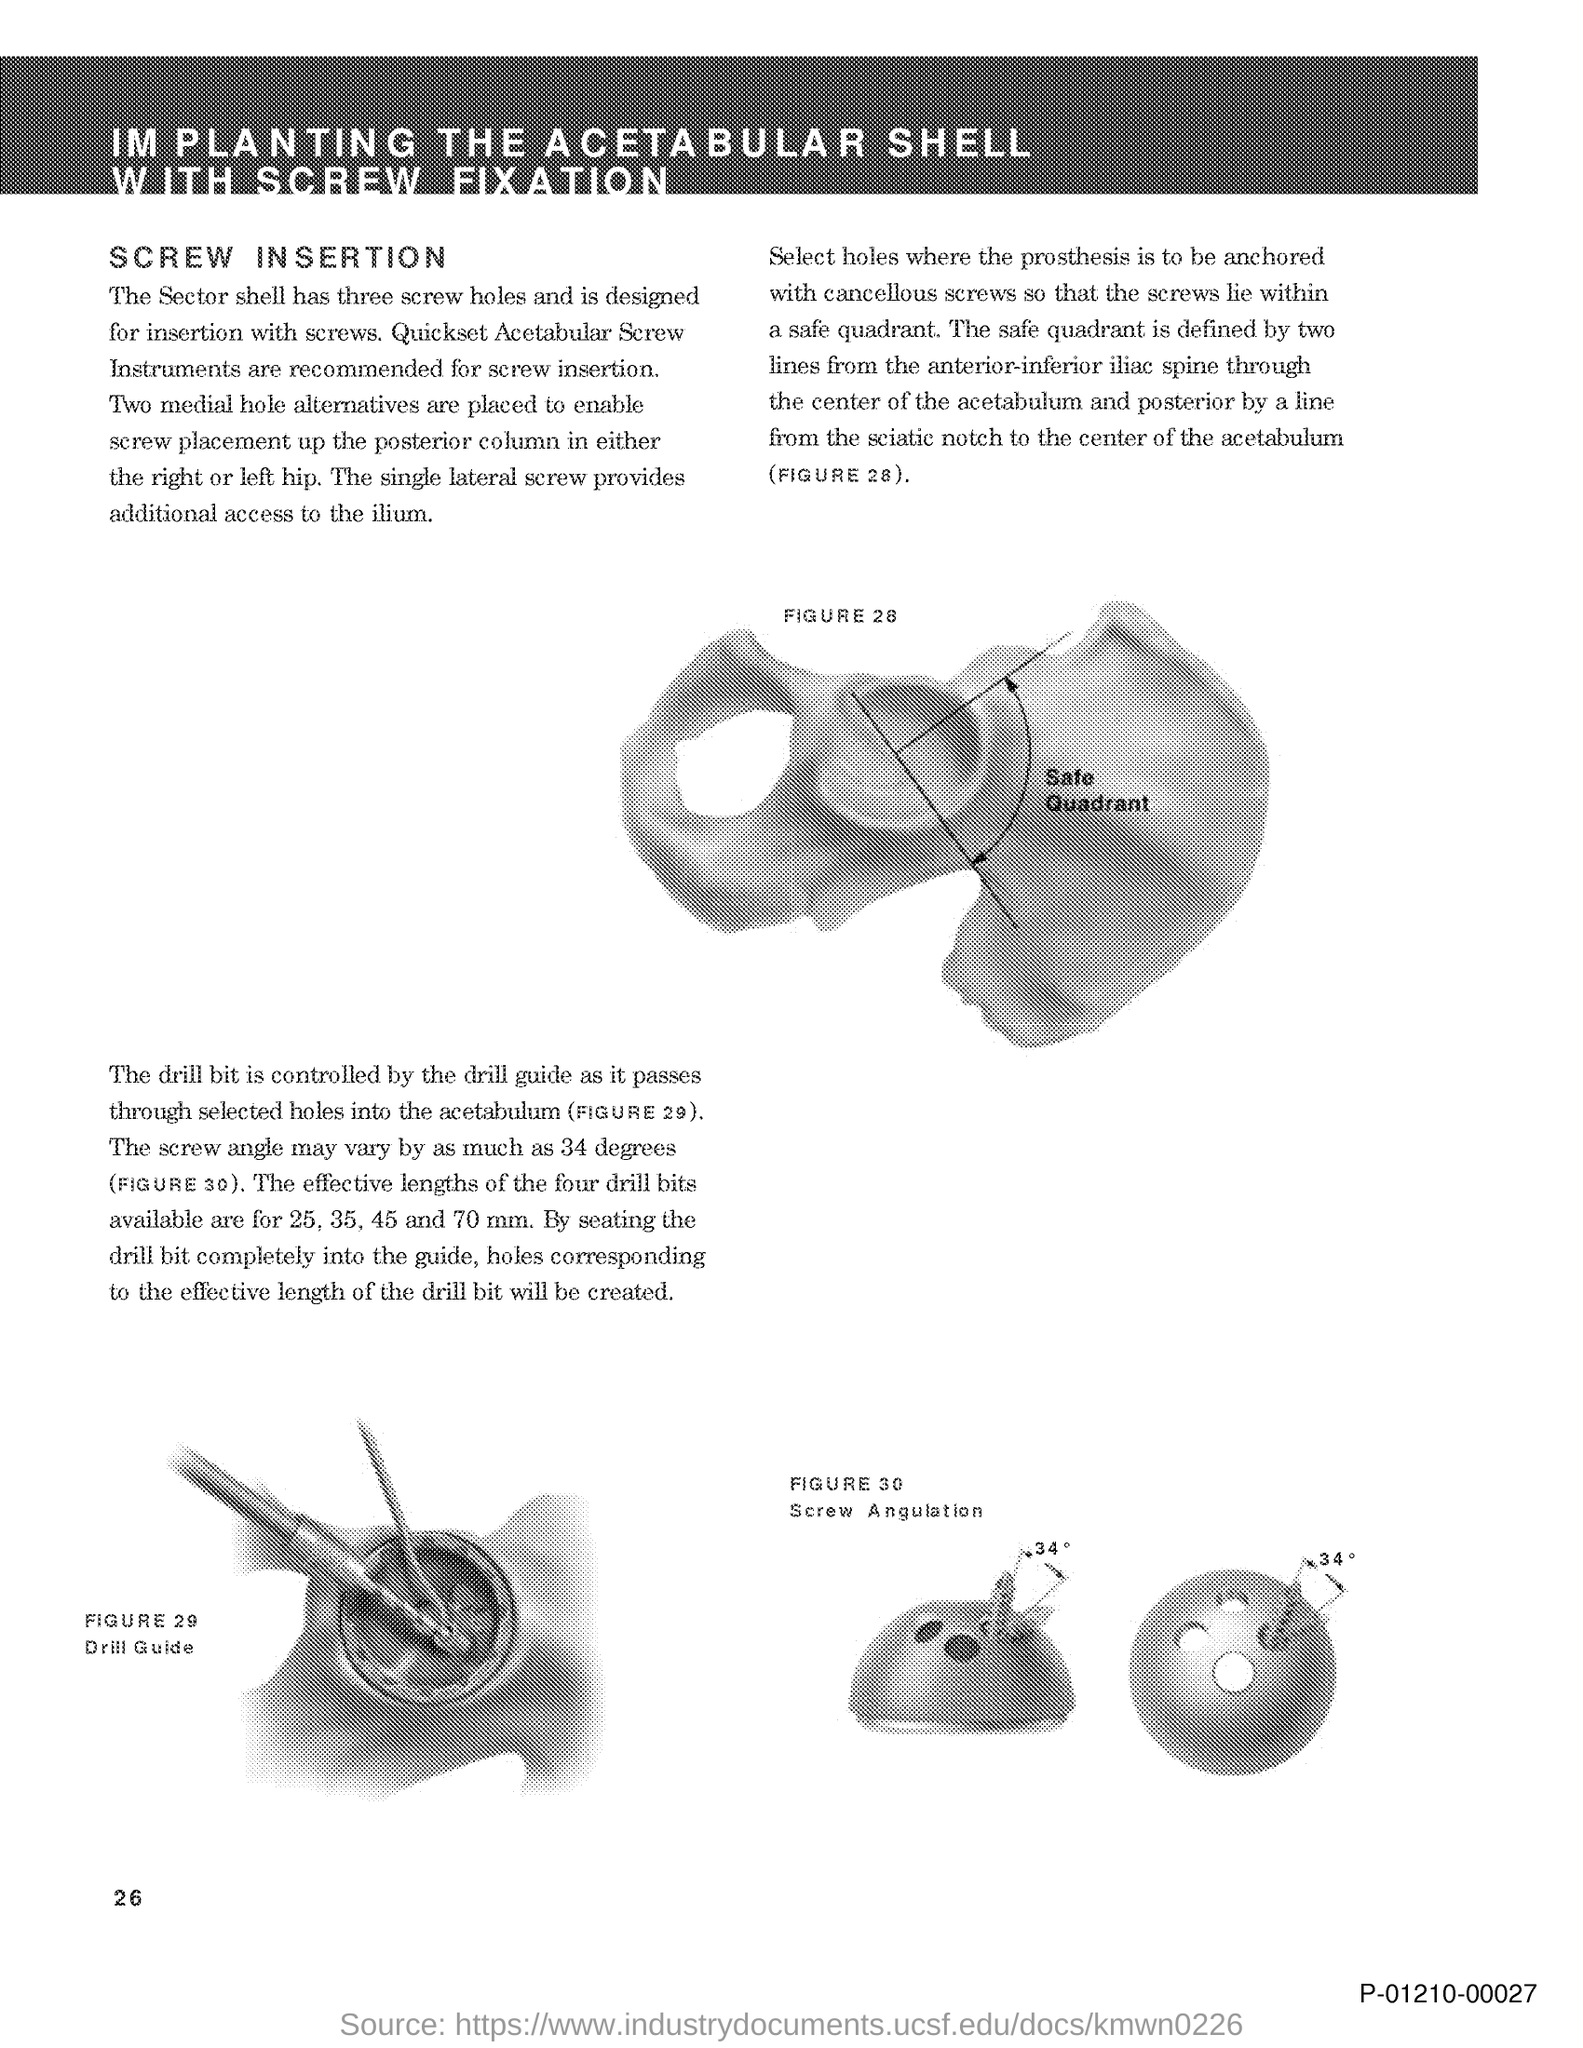What is the title of this document?
Your response must be concise. Implanting the acetabular shell with screw fixation. 